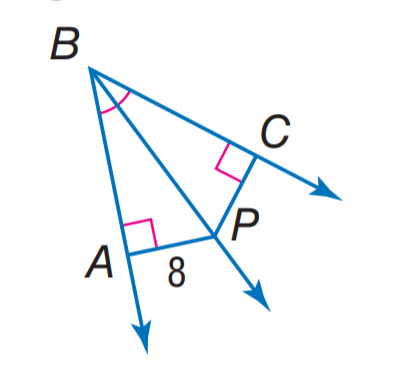Question: Find C P.
Choices:
A. 4
B. 8
C. 10
D. 12
Answer with the letter. Answer: B 